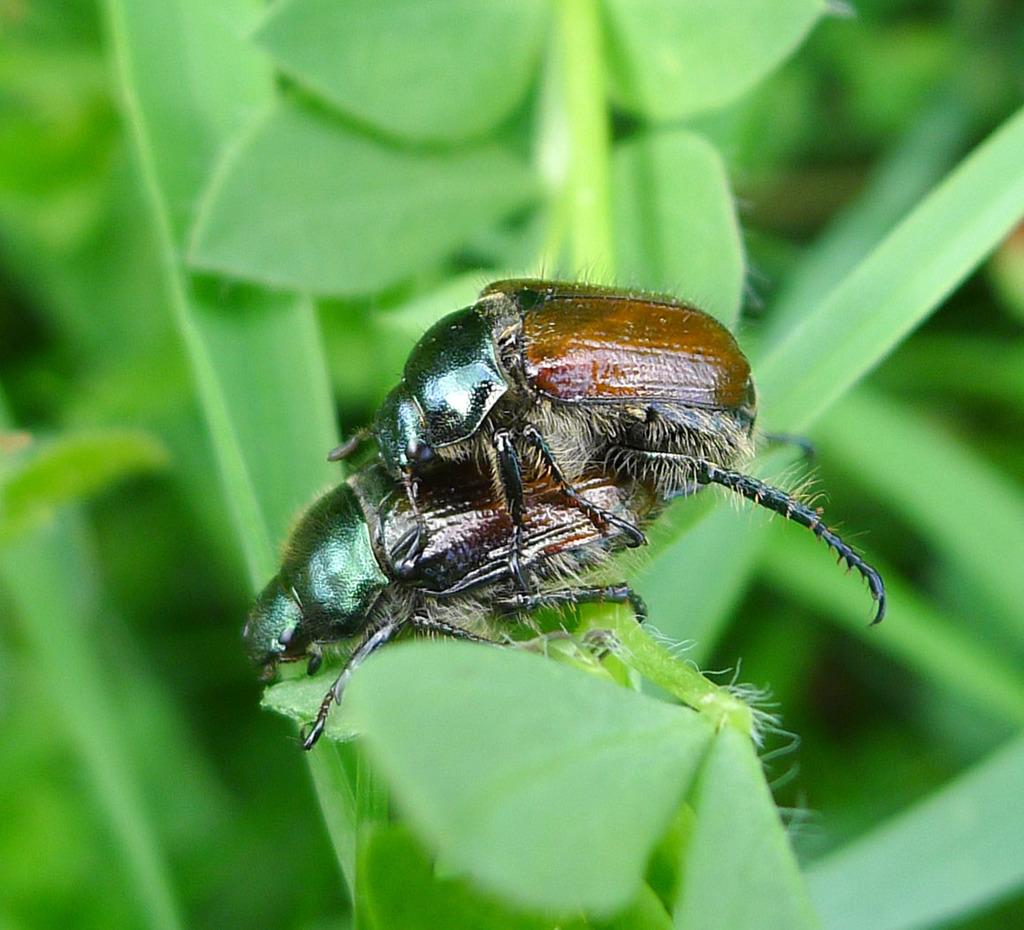What type of creatures can be seen in the image? There are insects in the image. Where are the insects located? The insects are on a plant. What book is the insect reading in the image? There is no book present in the image, as it features insects on a plant. What type of pain might the insects be experiencing in the image? There is no indication of pain or any emotional state for the insects in the image. 